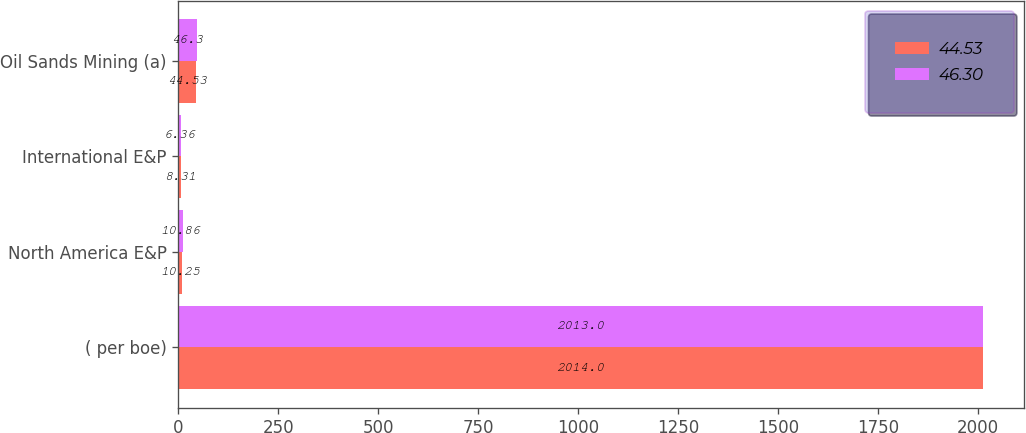<chart> <loc_0><loc_0><loc_500><loc_500><stacked_bar_chart><ecel><fcel>( per boe)<fcel>North America E&P<fcel>International E&P<fcel>Oil Sands Mining (a)<nl><fcel>44.53<fcel>2014<fcel>10.25<fcel>8.31<fcel>44.53<nl><fcel>46.3<fcel>2013<fcel>10.86<fcel>6.36<fcel>46.3<nl></chart> 